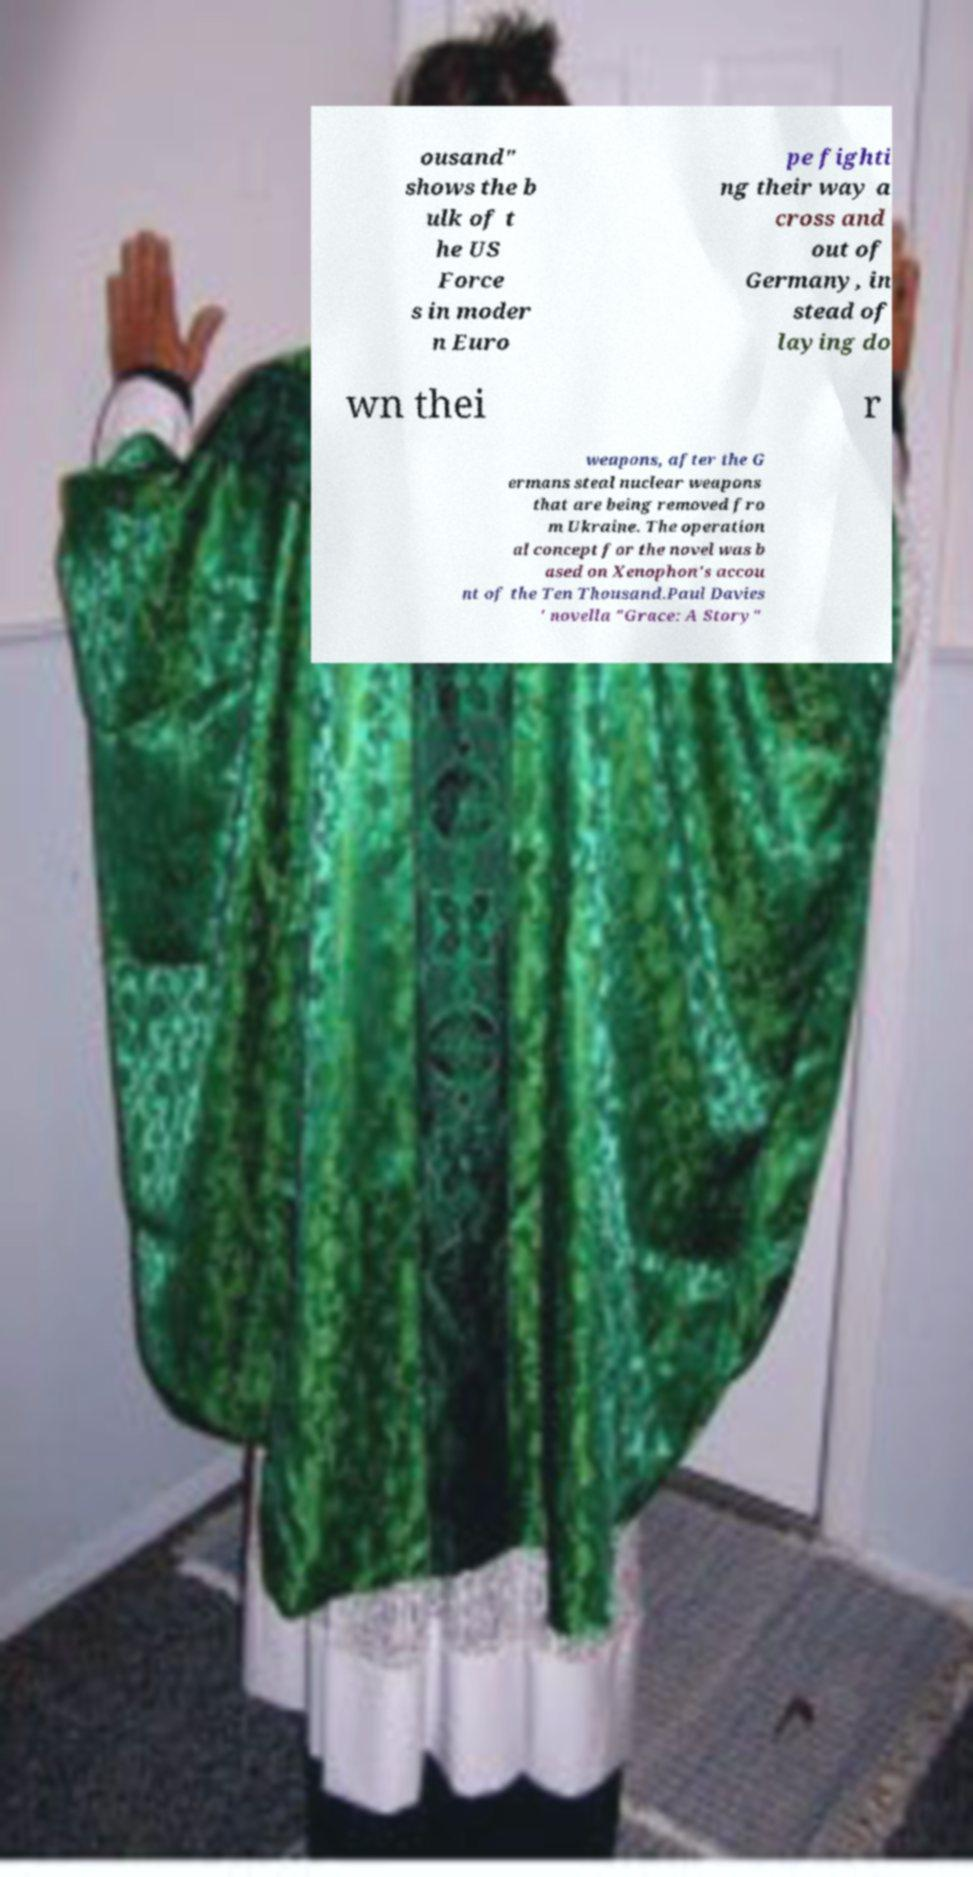Please read and relay the text visible in this image. What does it say? ousand" shows the b ulk of t he US Force s in moder n Euro pe fighti ng their way a cross and out of Germany, in stead of laying do wn thei r weapons, after the G ermans steal nuclear weapons that are being removed fro m Ukraine. The operation al concept for the novel was b ased on Xenophon's accou nt of the Ten Thousand.Paul Davies ' novella "Grace: A Story" 